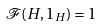Convert formula to latex. <formula><loc_0><loc_0><loc_500><loc_500>\mathcal { F } ( H , 1 _ { H } ) = 1</formula> 